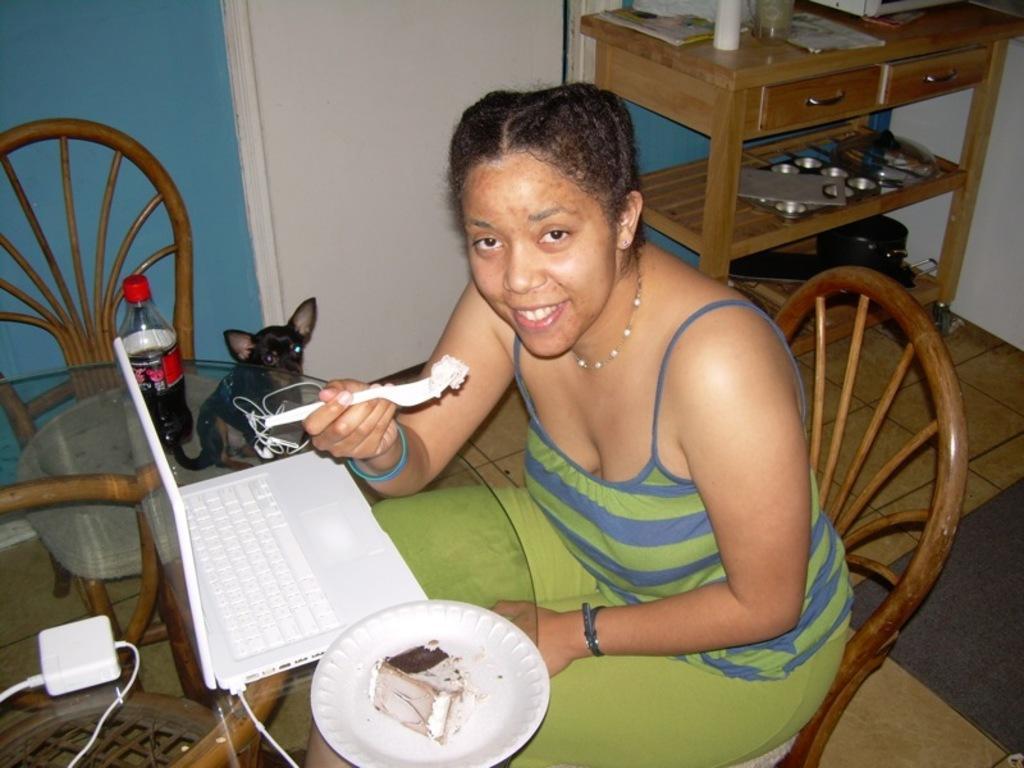How would you summarize this image in a sentence or two? In this image in the center there is a woman sitting and smiling and holding a spoon in her hand. In front of the woman there is food on the plate and there is a laptop and there is a bottle on the table and there is an adapter which is white in colour. There is an empty chair and there is a black colour animal on the ground and in the background there is a door which is white in colour and there is a table, on the table there are objects. 